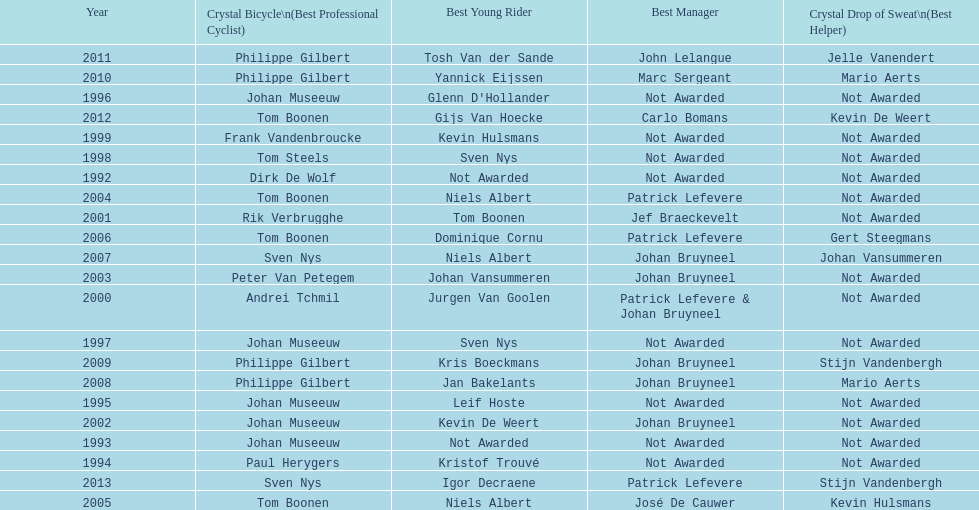What is the average number of times johan museeuw starred? 5. 